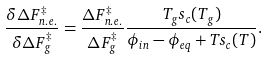Convert formula to latex. <formula><loc_0><loc_0><loc_500><loc_500>\frac { \delta \Delta F _ { n . e . } ^ { \ddagger } } { \delta \Delta F _ { g } ^ { \ddagger } } = \frac { \Delta F _ { n . e . } ^ { \ddagger } } { \Delta F _ { g } ^ { \ddagger } } \frac { T _ { g } s _ { c } ( T _ { g } ) } { \phi _ { i n } - \phi _ { e q } + T s _ { c } ( T ) } .</formula> 